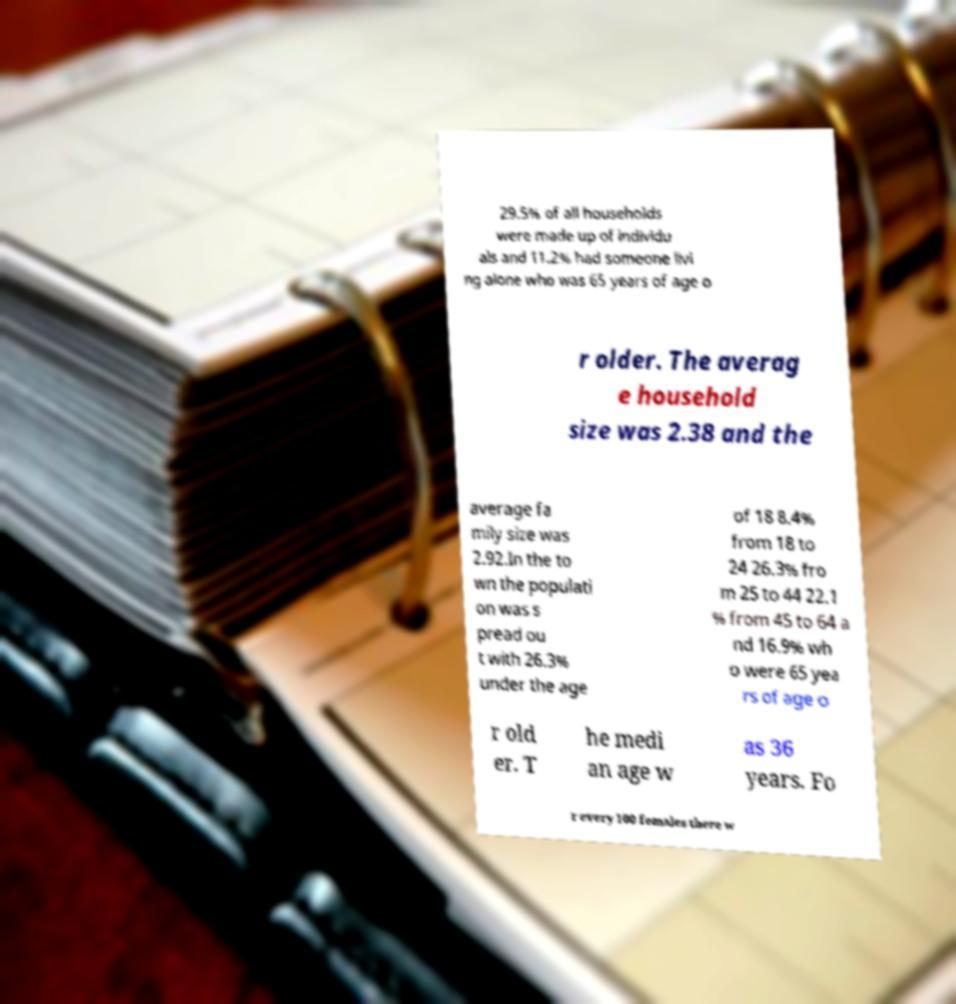Can you accurately transcribe the text from the provided image for me? 29.5% of all households were made up of individu als and 11.2% had someone livi ng alone who was 65 years of age o r older. The averag e household size was 2.38 and the average fa mily size was 2.92.In the to wn the populati on was s pread ou t with 26.3% under the age of 18 8.4% from 18 to 24 26.3% fro m 25 to 44 22.1 % from 45 to 64 a nd 16.9% wh o were 65 yea rs of age o r old er. T he medi an age w as 36 years. Fo r every 100 females there w 